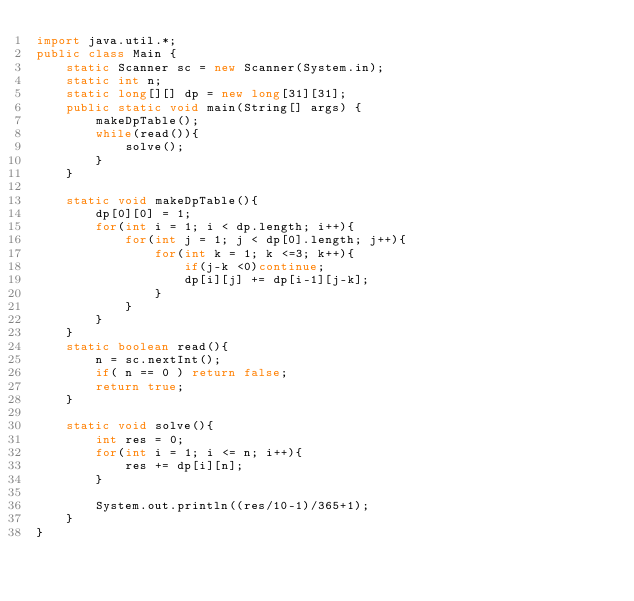Convert code to text. <code><loc_0><loc_0><loc_500><loc_500><_Java_>import java.util.*;
public class Main {
    static Scanner sc = new Scanner(System.in);
    static int n;
    static long[][] dp = new long[31][31];
    public static void main(String[] args) {
        makeDpTable();
        while(read()){
            solve();
        }
    }

    static void makeDpTable(){
        dp[0][0] = 1;
        for(int i = 1; i < dp.length; i++){
            for(int j = 1; j < dp[0].length; j++){
                for(int k = 1; k <=3; k++){
                    if(j-k <0)continue;
                    dp[i][j] += dp[i-1][j-k];
                }
            }
        }
    }
    static boolean read(){
        n = sc.nextInt();
        if( n == 0 ) return false;
        return true;
    }

    static void solve(){
        int res = 0;
        for(int i = 1; i <= n; i++){
            res += dp[i][n];
        }

        System.out.println((res/10-1)/365+1);
    }
}</code> 